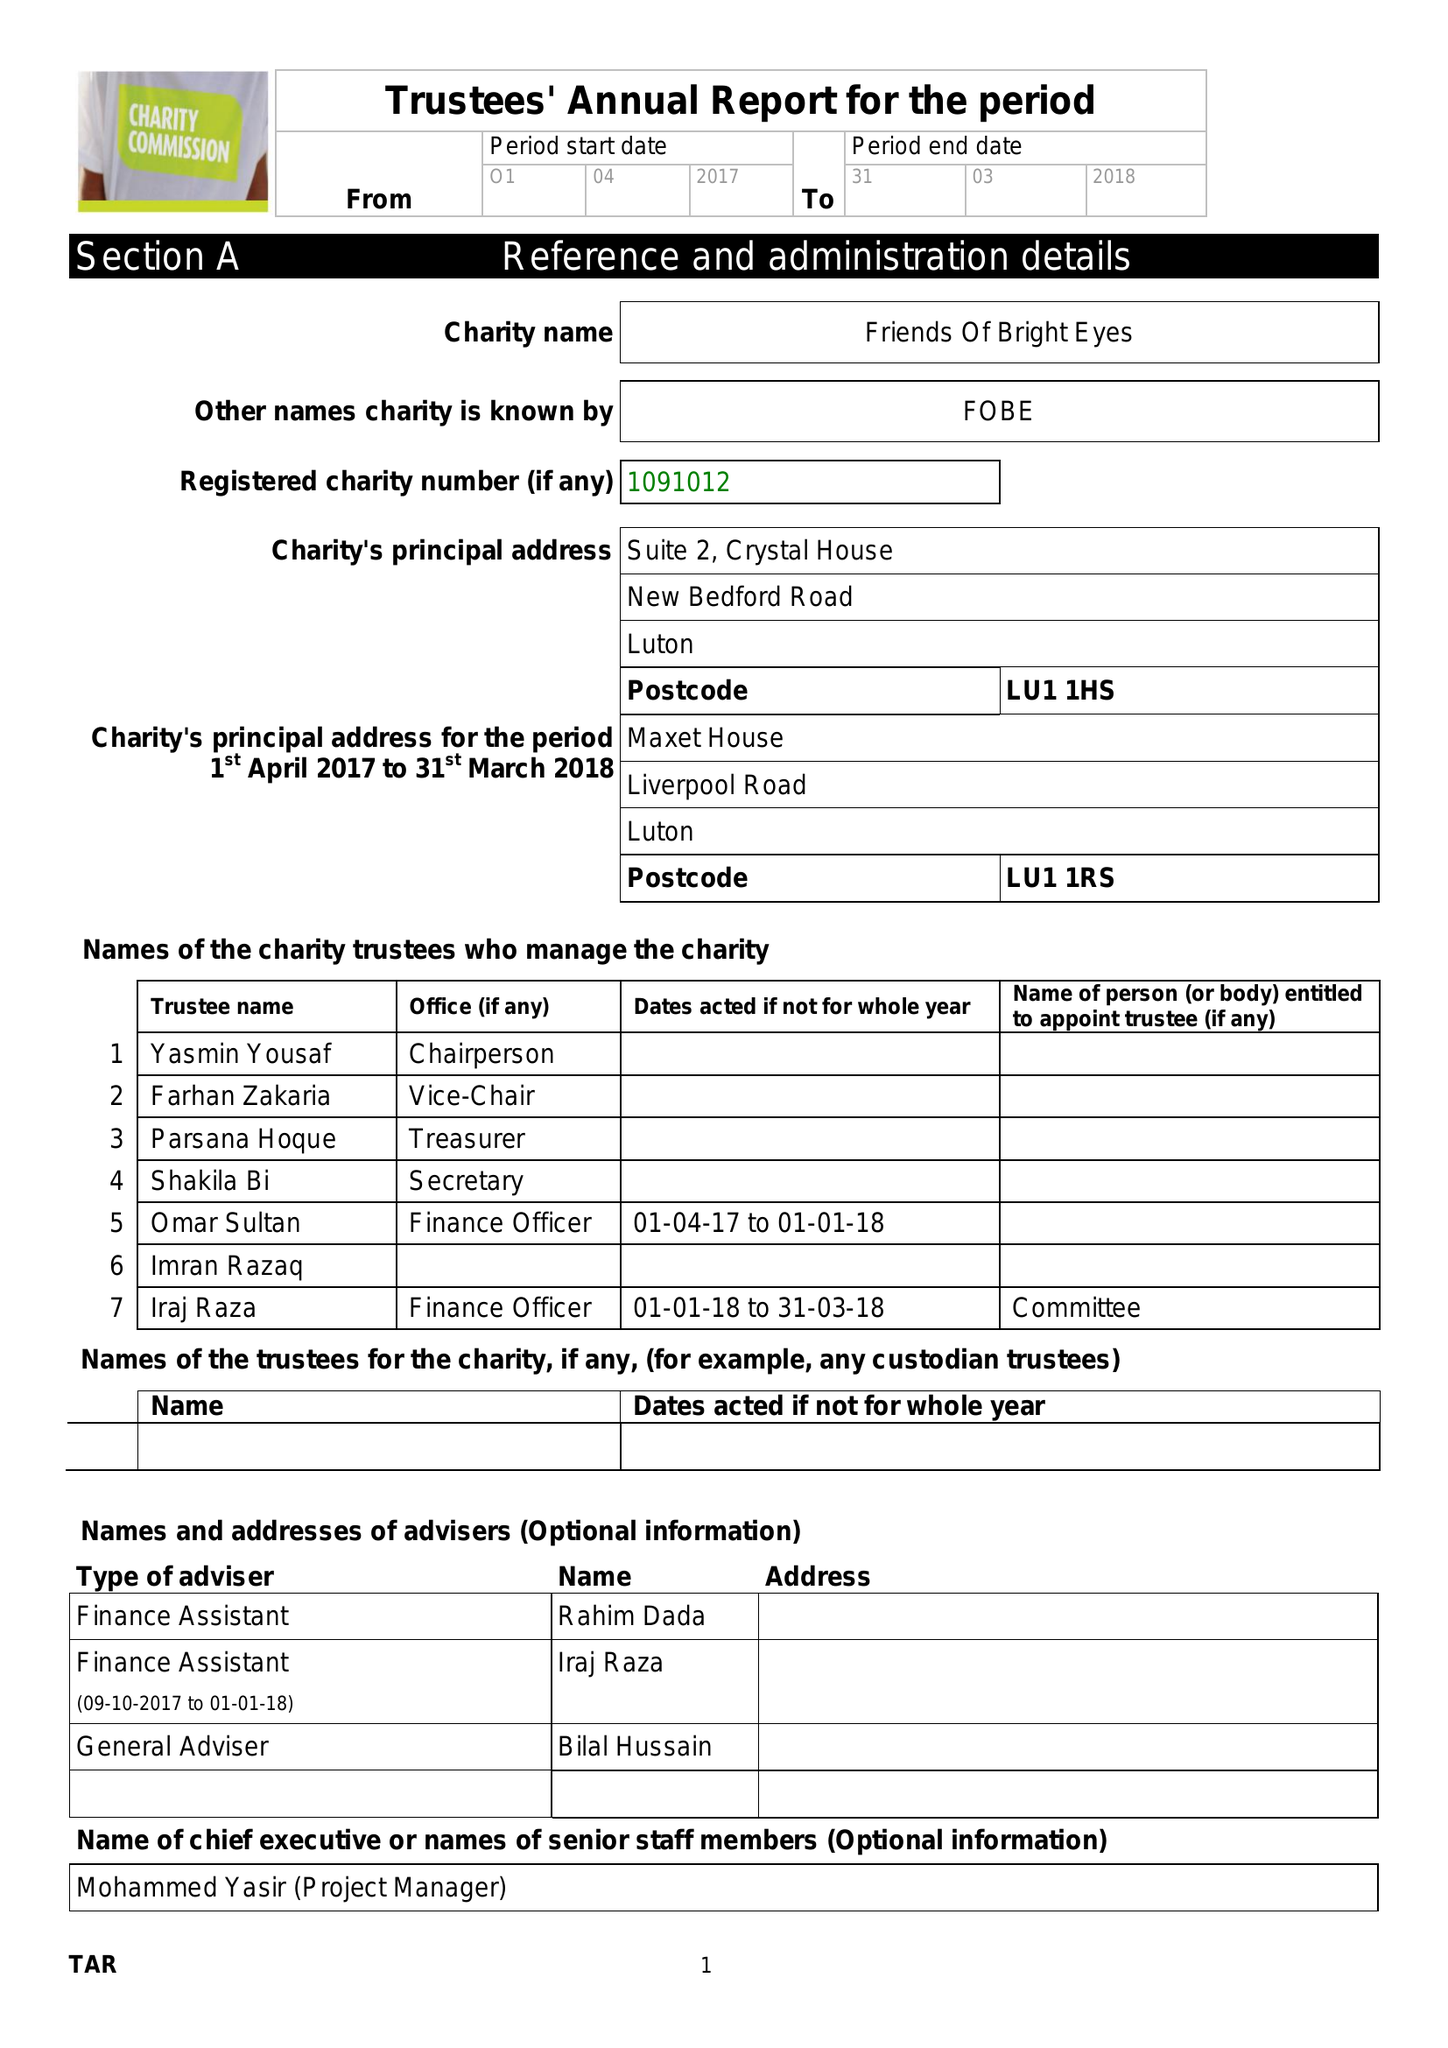What is the value for the address__post_town?
Answer the question using a single word or phrase. LUTON 